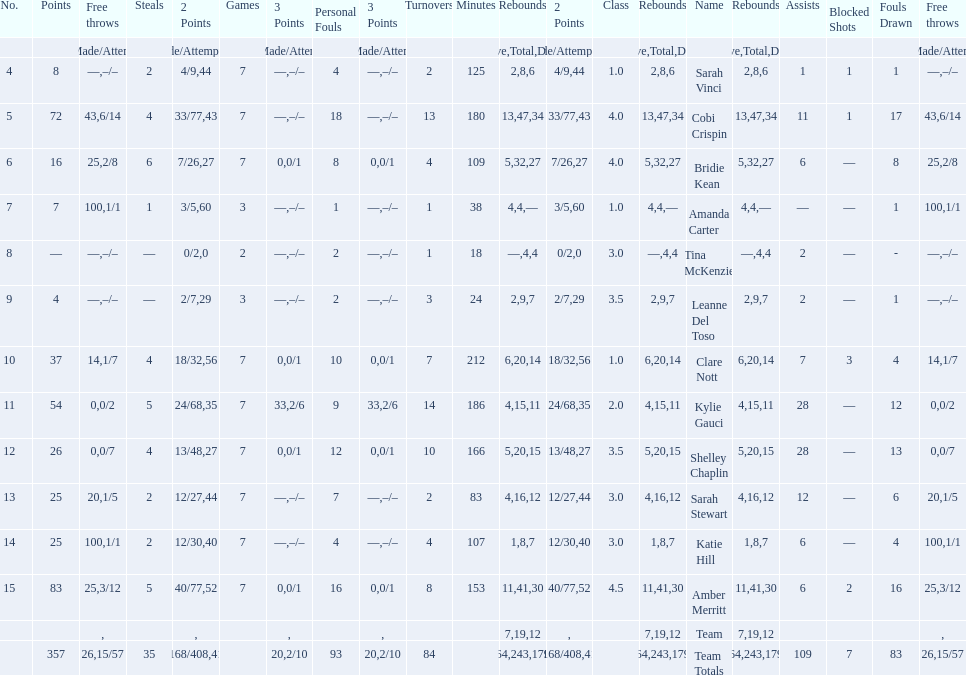Would you mind parsing the complete table? {'header': ['No.', 'Points', 'Free throws', 'Steals', '2 Points', 'Games', '3 Points', 'Personal Fouls', '3 Points', 'Turnovers', 'Minutes', 'Rebounds', '2 Points', 'Class', 'Rebounds', 'Name', 'Rebounds', 'Assists', 'Blocked Shots', 'Fouls Drawn', 'Free throws'], 'rows': [['', '', '%', '', 'Made/Attempts', '', '%', '', 'Made/Attempts', '', '', 'Offensive', '%', '', 'Total', '', 'Defensive', '', '', '', 'Made/Attempts'], ['4', '8', '—', '2', '4/9', '7', '—', '4', '–/–', '2', '125', '2', '44', '1.0', '8', 'Sarah Vinci', '6', '1', '1', '1', '–/–'], ['5', '72', '43', '4', '33/77', '7', '—', '18', '–/–', '13', '180', '13', '43', '4.0', '47', 'Cobi Crispin', '34', '11', '1', '17', '6/14'], ['6', '16', '25', '6', '7/26', '7', '0', '8', '0/1', '4', '109', '5', '27', '4.0', '32', 'Bridie Kean', '27', '6', '—', '8', '2/8'], ['7', '7', '100', '1', '3/5', '3', '—', '1', '–/–', '1', '38', '4', '60', '1.0', '4', 'Amanda Carter', '—', '—', '—', '1', '1/1'], ['8', '—', '—', '—', '0/2', '2', '—', '2', '–/–', '1', '18', '—', '0', '3.0', '4', 'Tina McKenzie', '4', '2', '—', '-', '–/–'], ['9', '4', '—', '—', '2/7', '3', '—', '2', '–/–', '3', '24', '2', '29', '3.5', '9', 'Leanne Del Toso', '7', '2', '—', '1', '–/–'], ['10', '37', '14', '4', '18/32', '7', '0', '10', '0/1', '7', '212', '6', '56', '1.0', '20', 'Clare Nott', '14', '7', '3', '4', '1/7'], ['11', '54', '0', '5', '24/68', '7', '33', '9', '2/6', '14', '186', '4', '35', '2.0', '15', 'Kylie Gauci', '11', '28', '—', '12', '0/2'], ['12', '26', '0', '4', '13/48', '7', '0', '12', '0/1', '10', '166', '5', '27', '3.5', '20', 'Shelley Chaplin', '15', '28', '—', '13', '0/7'], ['13', '25', '20', '2', '12/27', '7', '—', '7', '–/–', '2', '83', '4', '44', '3.0', '16', 'Sarah Stewart', '12', '12', '—', '6', '1/5'], ['14', '25', '100', '2', '12/30', '7', '—', '4', '–/–', '4', '107', '1', '40', '3.0', '8', 'Katie Hill', '7', '6', '—', '4', '1/1'], ['15', '83', '25', '5', '40/77', '7', '0', '16', '0/1', '8', '153', '11', '52', '4.5', '41', 'Amber Merritt', '30', '6', '2', '16', '3/12'], ['', '', '', '', '', '', '', '', '', '', '', '7', '', '', '19', 'Team', '12', '', '', '', ''], ['', '357', '26', '35', '168/408', '', '20', '93', '2/10', '84', '', '64', '41', '', '243', 'Team Totals', '179', '109', '7', '83', '15/57']]} Total number of assists and turnovers combined 193. 